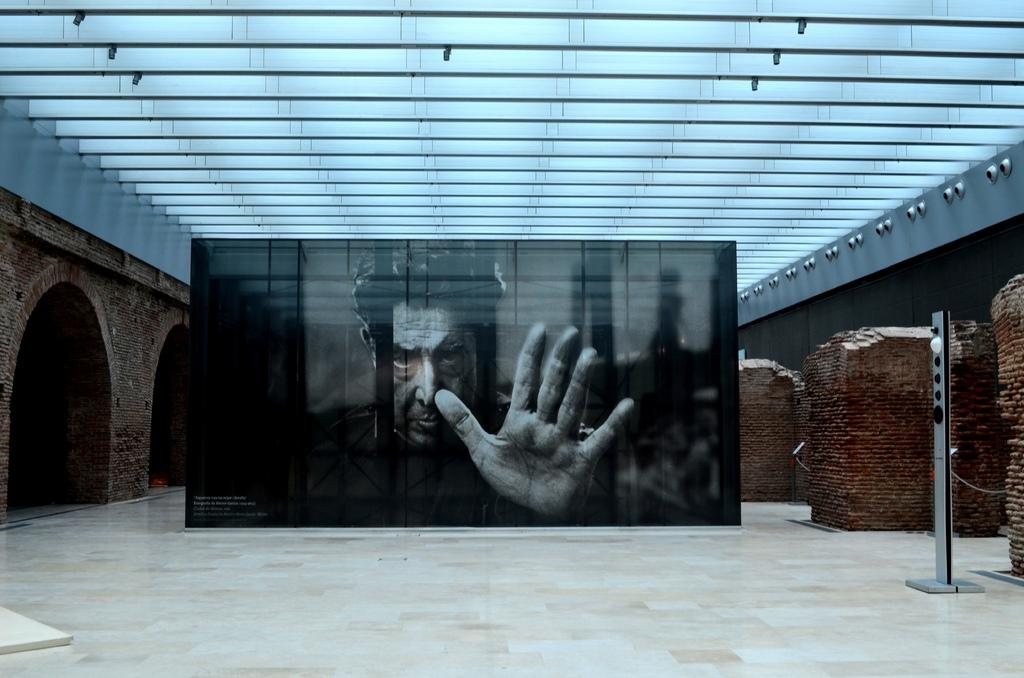What is the main subject of the image? There is a portrait of a man in the image. What architectural features can be seen on the left side of the image? There are two arches on the left side of the image. What type of structure is visible on the right side of the image? There are walls on the right side of the image. What type of sugar can be seen rolling on the floor in the image? There is no sugar or rolling motion present in the image; it features a portrait of a man and architectural elements. 